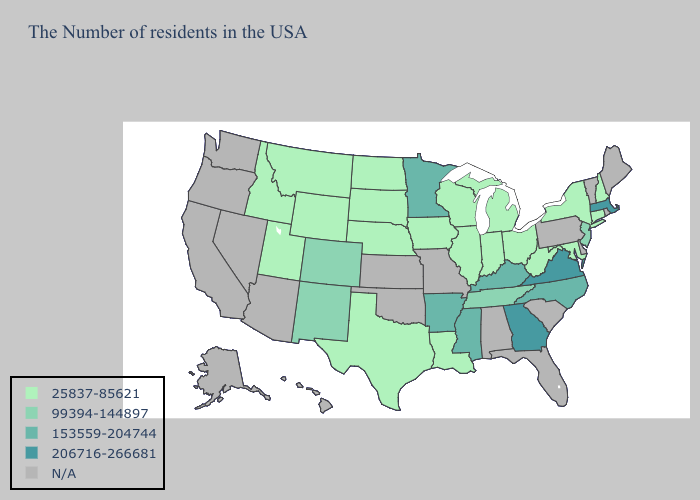Which states have the highest value in the USA?
Answer briefly. Massachusetts, Virginia, Georgia. Name the states that have a value in the range 206716-266681?
Short answer required. Massachusetts, Virginia, Georgia. Name the states that have a value in the range 25837-85621?
Concise answer only. New Hampshire, Connecticut, New York, Maryland, West Virginia, Ohio, Michigan, Indiana, Wisconsin, Illinois, Louisiana, Iowa, Nebraska, Texas, South Dakota, North Dakota, Wyoming, Utah, Montana, Idaho. What is the lowest value in states that border Georgia?
Be succinct. 99394-144897. Which states hav the highest value in the South?
Write a very short answer. Virginia, Georgia. Among the states that border Indiana , does Ohio have the lowest value?
Give a very brief answer. Yes. Name the states that have a value in the range 25837-85621?
Be succinct. New Hampshire, Connecticut, New York, Maryland, West Virginia, Ohio, Michigan, Indiana, Wisconsin, Illinois, Louisiana, Iowa, Nebraska, Texas, South Dakota, North Dakota, Wyoming, Utah, Montana, Idaho. What is the value of Wyoming?
Answer briefly. 25837-85621. Does Massachusetts have the highest value in the USA?
Short answer required. Yes. What is the value of Alaska?
Answer briefly. N/A. What is the lowest value in states that border New Mexico?
Concise answer only. 25837-85621. What is the lowest value in the USA?
Keep it brief. 25837-85621. Among the states that border Oklahoma , does Arkansas have the highest value?
Be succinct. Yes. Among the states that border Mississippi , does Louisiana have the lowest value?
Answer briefly. Yes. Name the states that have a value in the range 25837-85621?
Answer briefly. New Hampshire, Connecticut, New York, Maryland, West Virginia, Ohio, Michigan, Indiana, Wisconsin, Illinois, Louisiana, Iowa, Nebraska, Texas, South Dakota, North Dakota, Wyoming, Utah, Montana, Idaho. 